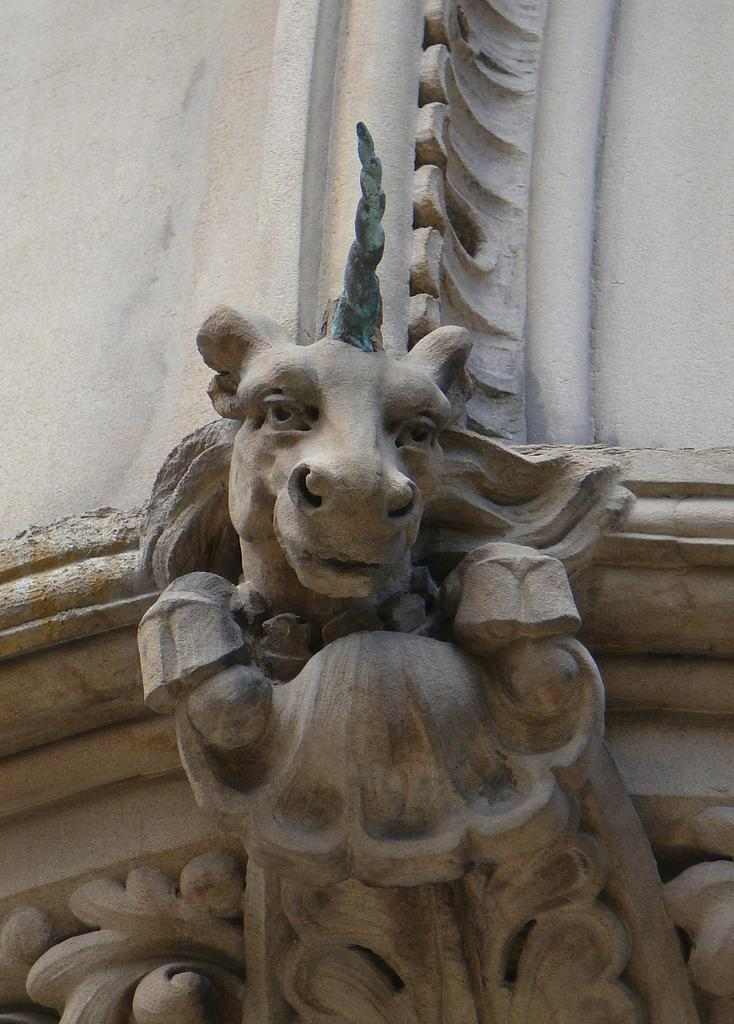What is the main subject in the image? There is a sculpture in the image. How many ants can be seen crawling on the sculpture in the image? There is no mention of ants in the image, so it is not possible to determine how many ants might be present. 